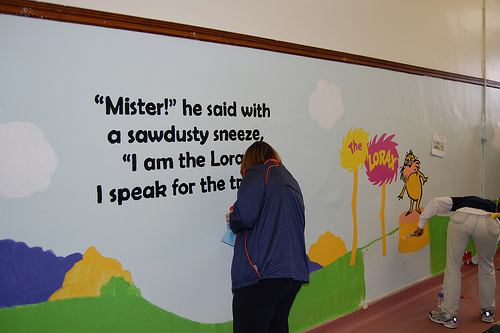<image>
Is the woman in front of the wall? Yes. The woman is positioned in front of the wall, appearing closer to the camera viewpoint. 